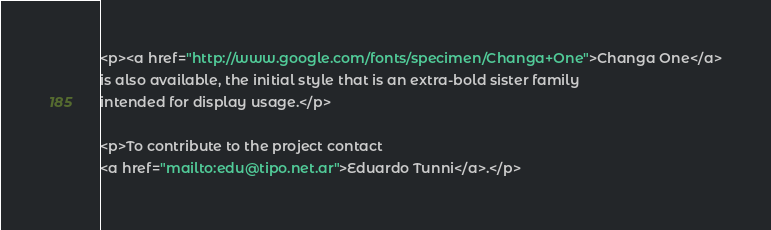Convert code to text. <code><loc_0><loc_0><loc_500><loc_500><_HTML_><p><a href="http://www.google.com/fonts/specimen/Changa+One">Changa One</a>
is also available, the initial style that is an extra-bold sister family 
intended for display usage.</p>

<p>To contribute to the project contact
<a href="mailto:edu@tipo.net.ar">Eduardo Tunni</a>.</p></code> 